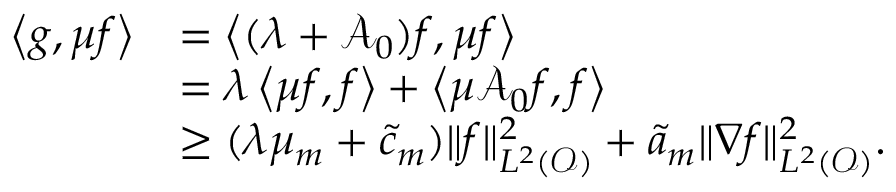Convert formula to latex. <formula><loc_0><loc_0><loc_500><loc_500>\begin{array} { r l } { \left < g , \mu f \right > } & { = \left < ( \lambda + \mathcal { A } _ { 0 } ) f , \mu f \right > } \\ & { = \lambda \left < \mu f , f \right > + \left < \mu \mathcal { A } _ { 0 } f , f \right > } \\ & { \geq ( \lambda \mu _ { m } + \tilde { c } _ { m } ) \| f \| _ { L ^ { 2 } ( \mathcal { O } ) } ^ { 2 } + \tilde { a } _ { m } \| \nabla f \| _ { L ^ { 2 } ( \mathcal { O } ) } ^ { 2 } . } \end{array}</formula> 